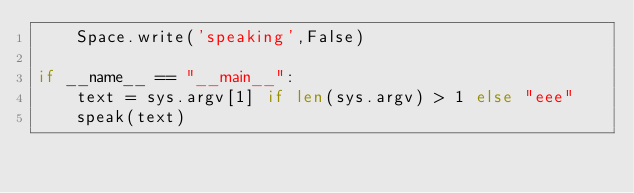Convert code to text. <code><loc_0><loc_0><loc_500><loc_500><_Python_>    Space.write('speaking',False)

if __name__ == "__main__":  
    text = sys.argv[1] if len(sys.argv) > 1 else "eee"
    speak(text)
    </code> 